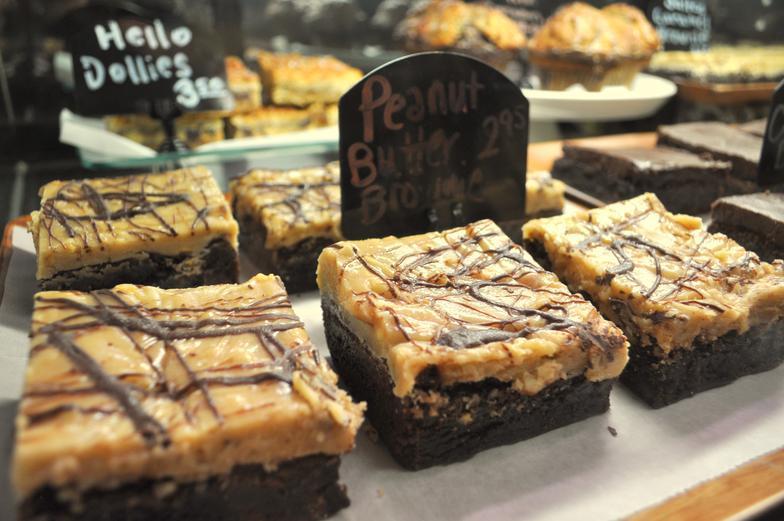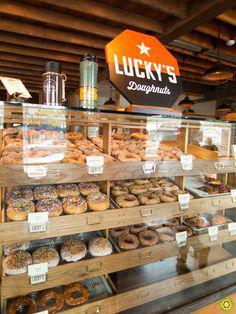The first image is the image on the left, the second image is the image on the right. Evaluate the accuracy of this statement regarding the images: "The labels are handwritten in one of the images.". Is it true? Answer yes or no. Yes. 